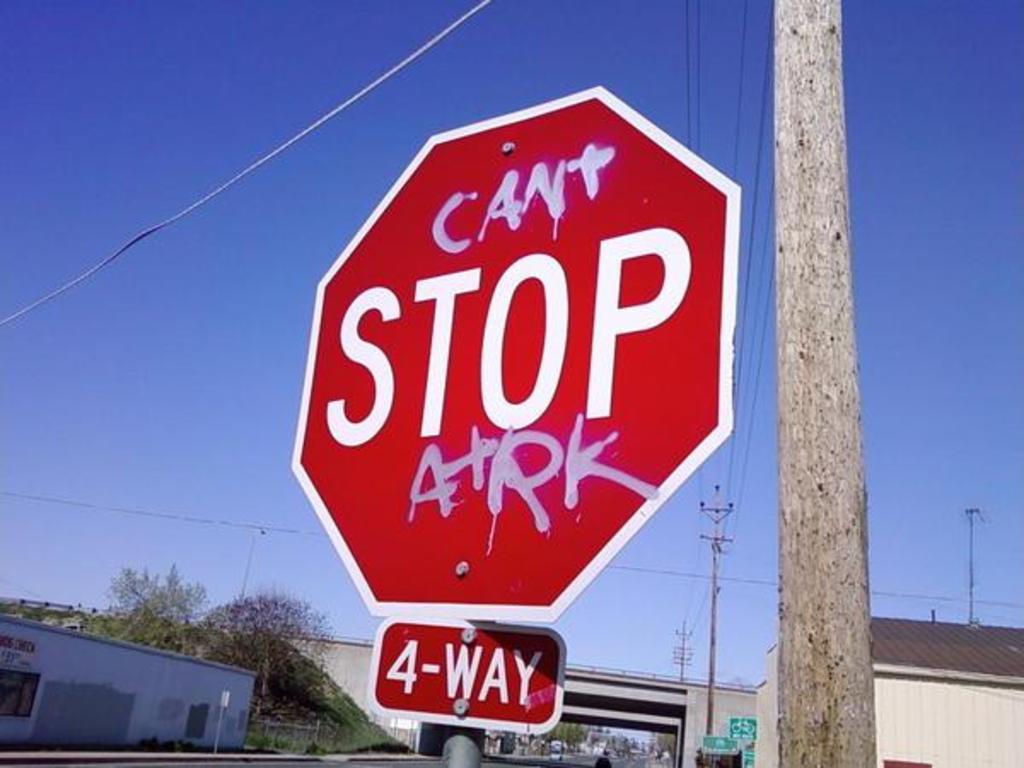What can't you stop?
Offer a terse response. Atrk. What kind of stop is it?
Give a very brief answer. 4-way. 